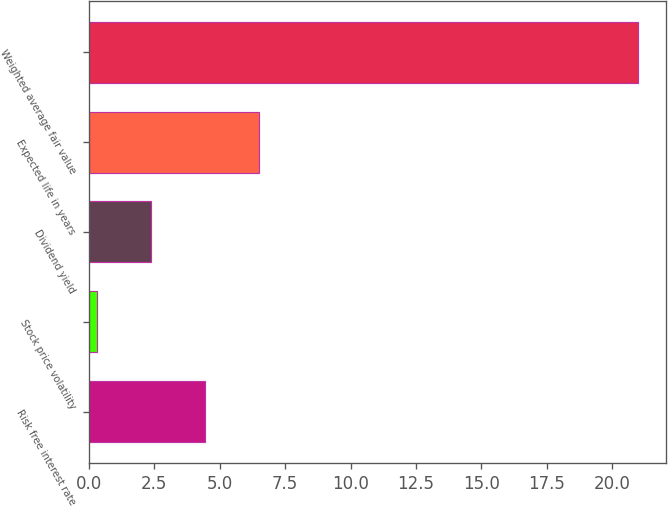Convert chart to OTSL. <chart><loc_0><loc_0><loc_500><loc_500><bar_chart><fcel>Risk free interest rate<fcel>Stock price volatility<fcel>Dividend yield<fcel>Expected life in years<fcel>Weighted average fair value<nl><fcel>4.45<fcel>0.31<fcel>2.38<fcel>6.52<fcel>21<nl></chart> 